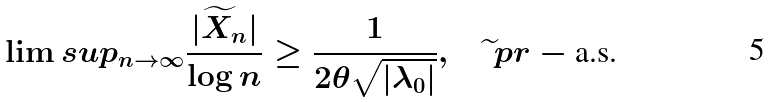Convert formula to latex. <formula><loc_0><loc_0><loc_500><loc_500>\lim s u p _ { n \to \infty } \frac { | \widetilde { X } _ { n } | } { \log n } \geq \frac { 1 } { 2 \theta \sqrt { | \lambda _ { 0 } | } } , \quad \widetilde { \ } p r - \text {a.s.}</formula> 